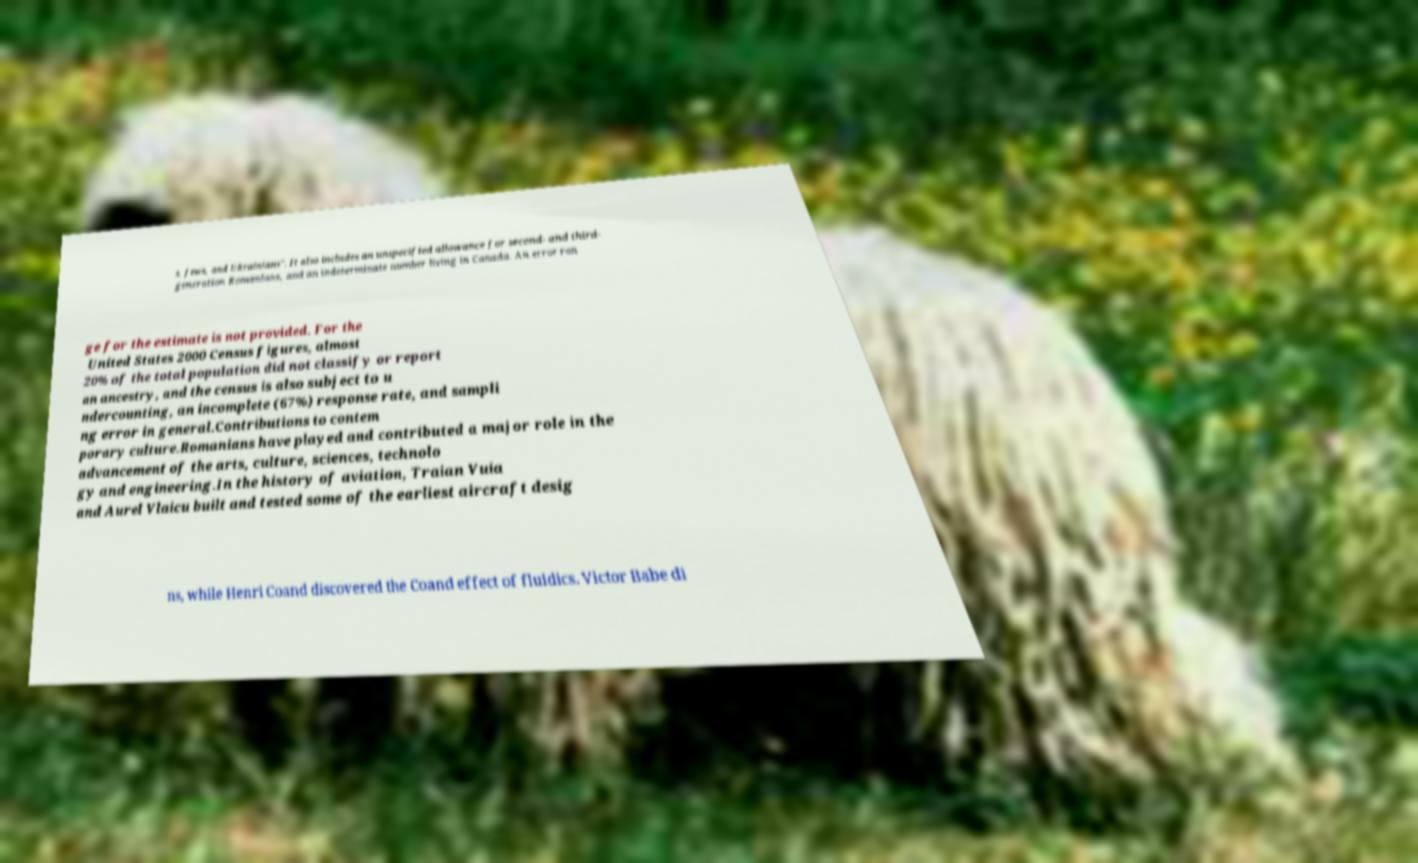I need the written content from this picture converted into text. Can you do that? s, Jews, and Ukrainians". It also includes an unspecified allowance for second- and third- generation Romanians, and an indeterminate number living in Canada. An error ran ge for the estimate is not provided. For the United States 2000 Census figures, almost 20% of the total population did not classify or report an ancestry, and the census is also subject to u ndercounting, an incomplete (67%) response rate, and sampli ng error in general.Contributions to contem porary culture.Romanians have played and contributed a major role in the advancement of the arts, culture, sciences, technolo gy and engineering.In the history of aviation, Traian Vuia and Aurel Vlaicu built and tested some of the earliest aircraft desig ns, while Henri Coand discovered the Coand effect of fluidics. Victor Babe di 